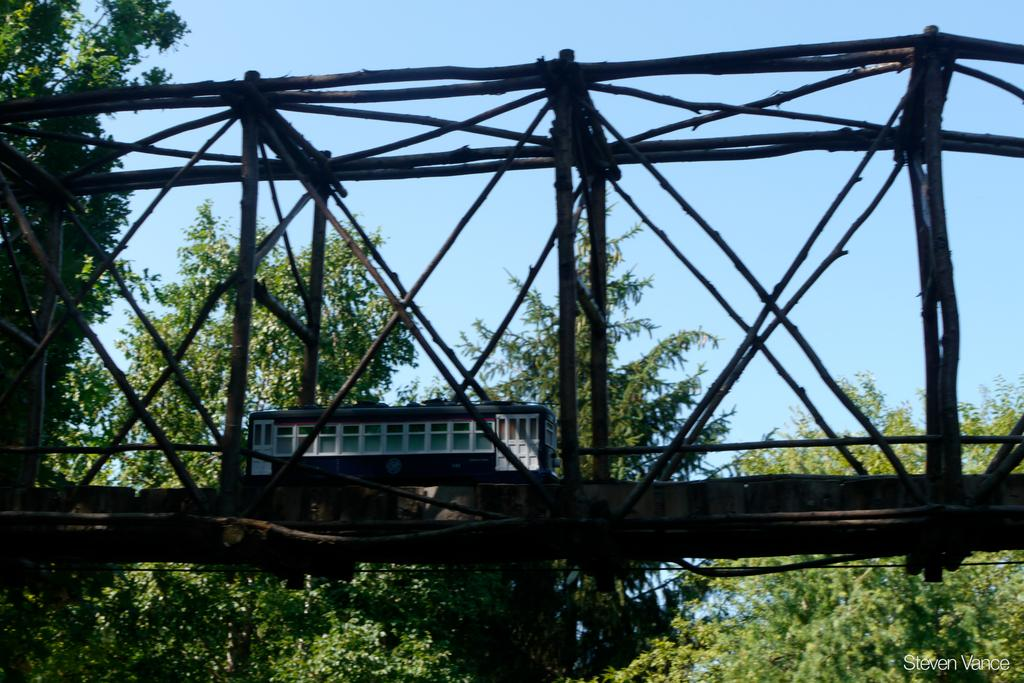What type of structure can be seen in the image? There is a bridge in the image. What else can be seen in the image besides the bridge? There are houses and trees with green color visible in the image. What is the color of the sky in the image? The sky is blue in the image. How many rings are visible on the goat's neck in the image? There is no goat present in the image, so it is not possible to determine the number of rings on its neck. 